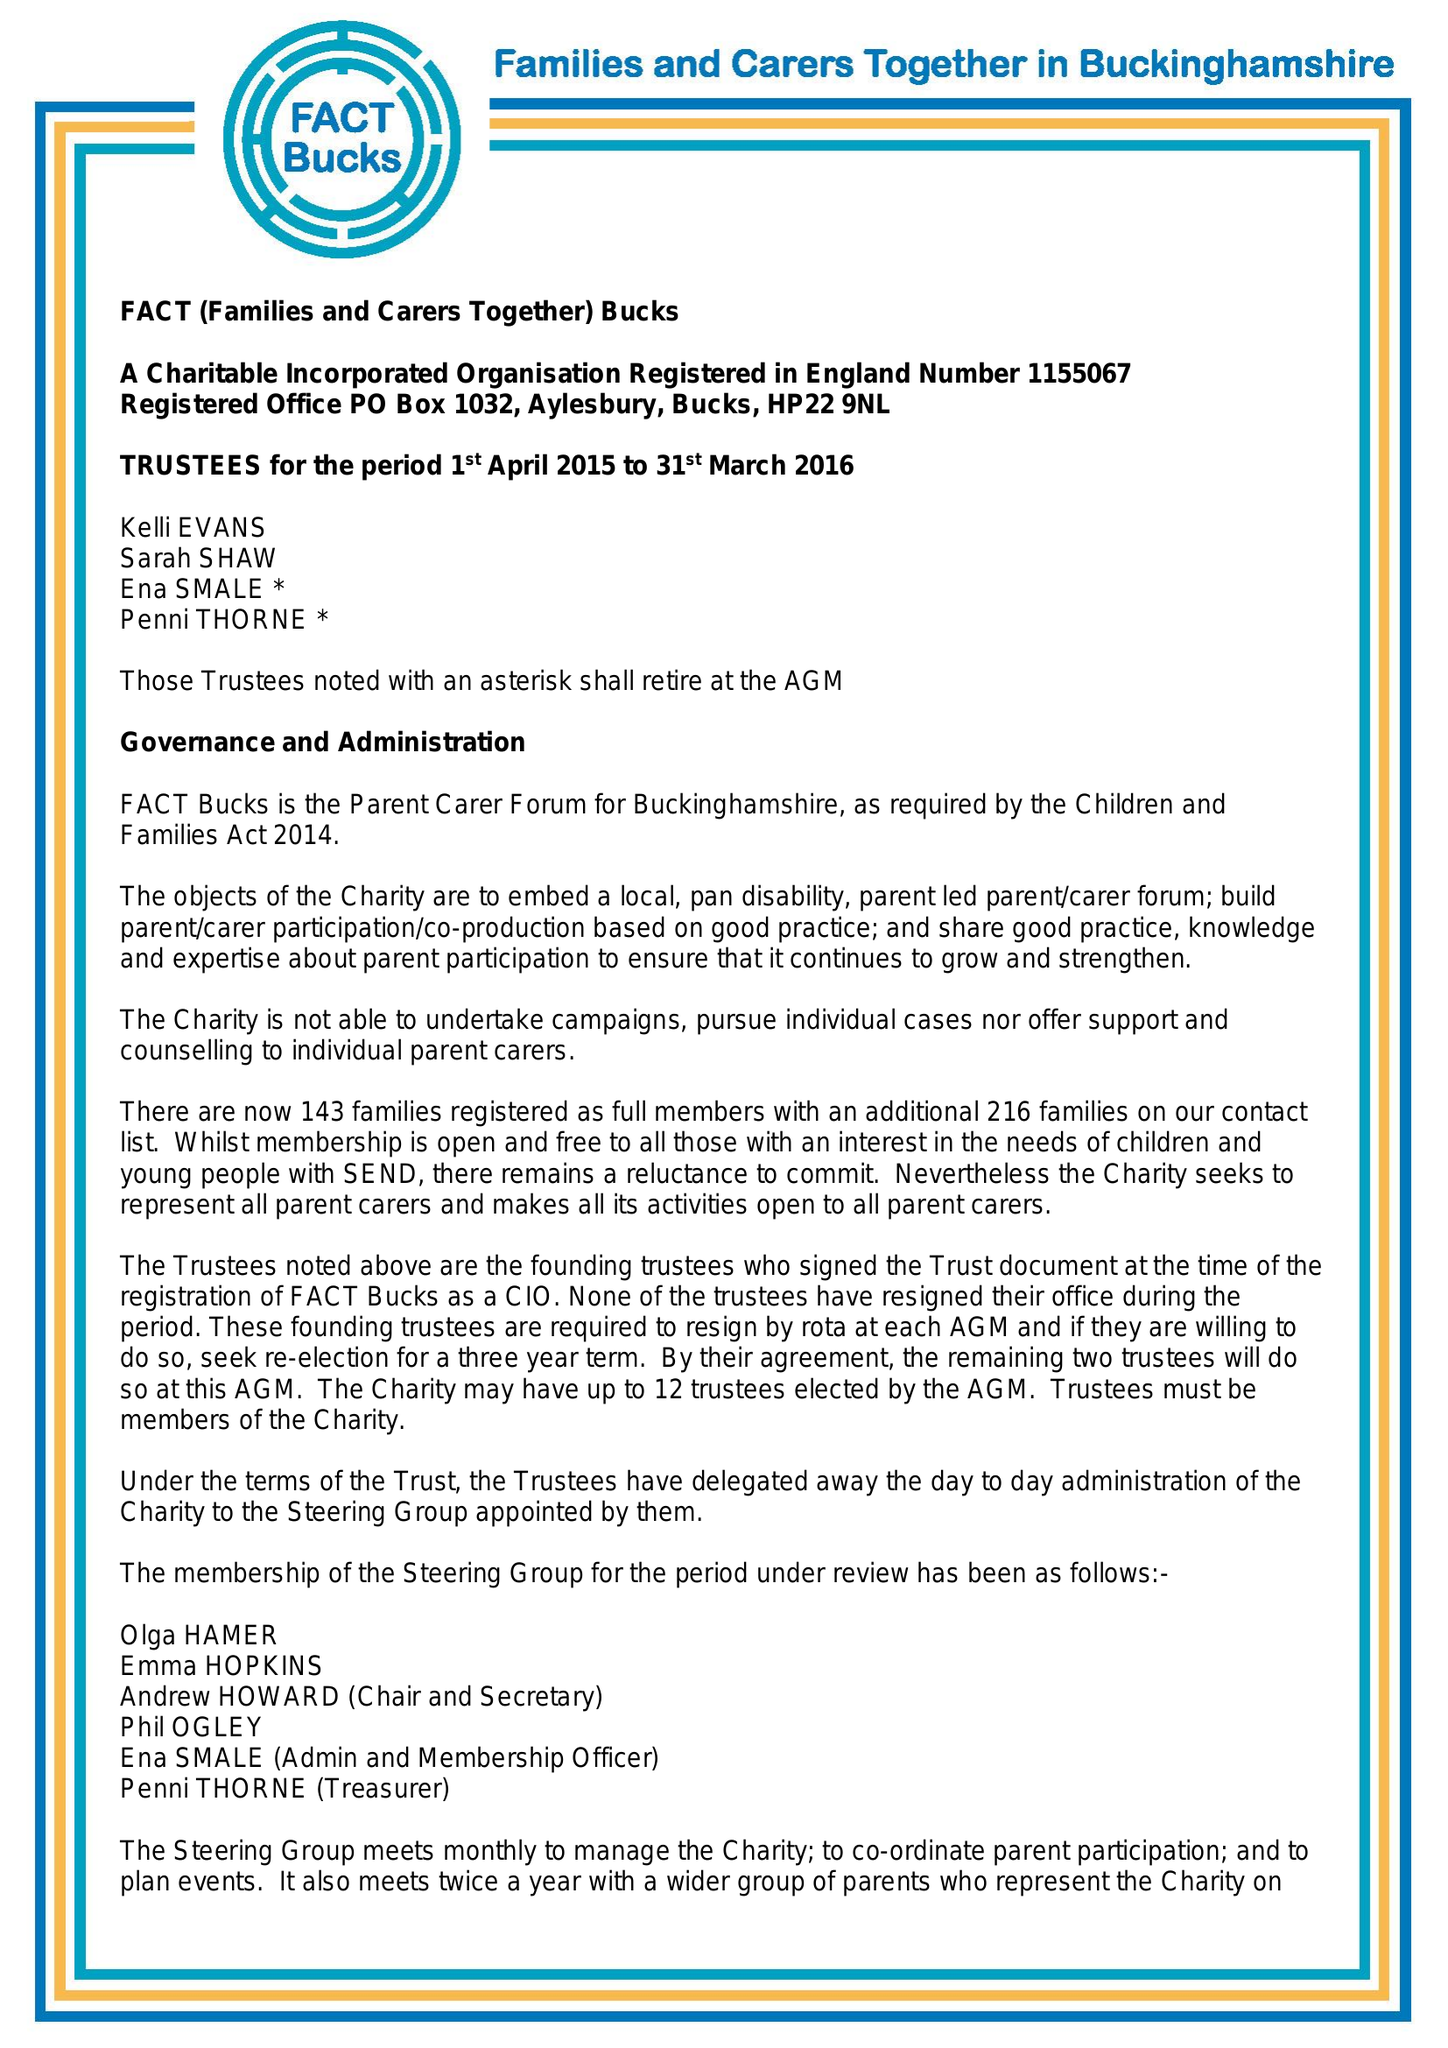What is the value for the address__postcode?
Answer the question using a single word or phrase. HP22 9NL 